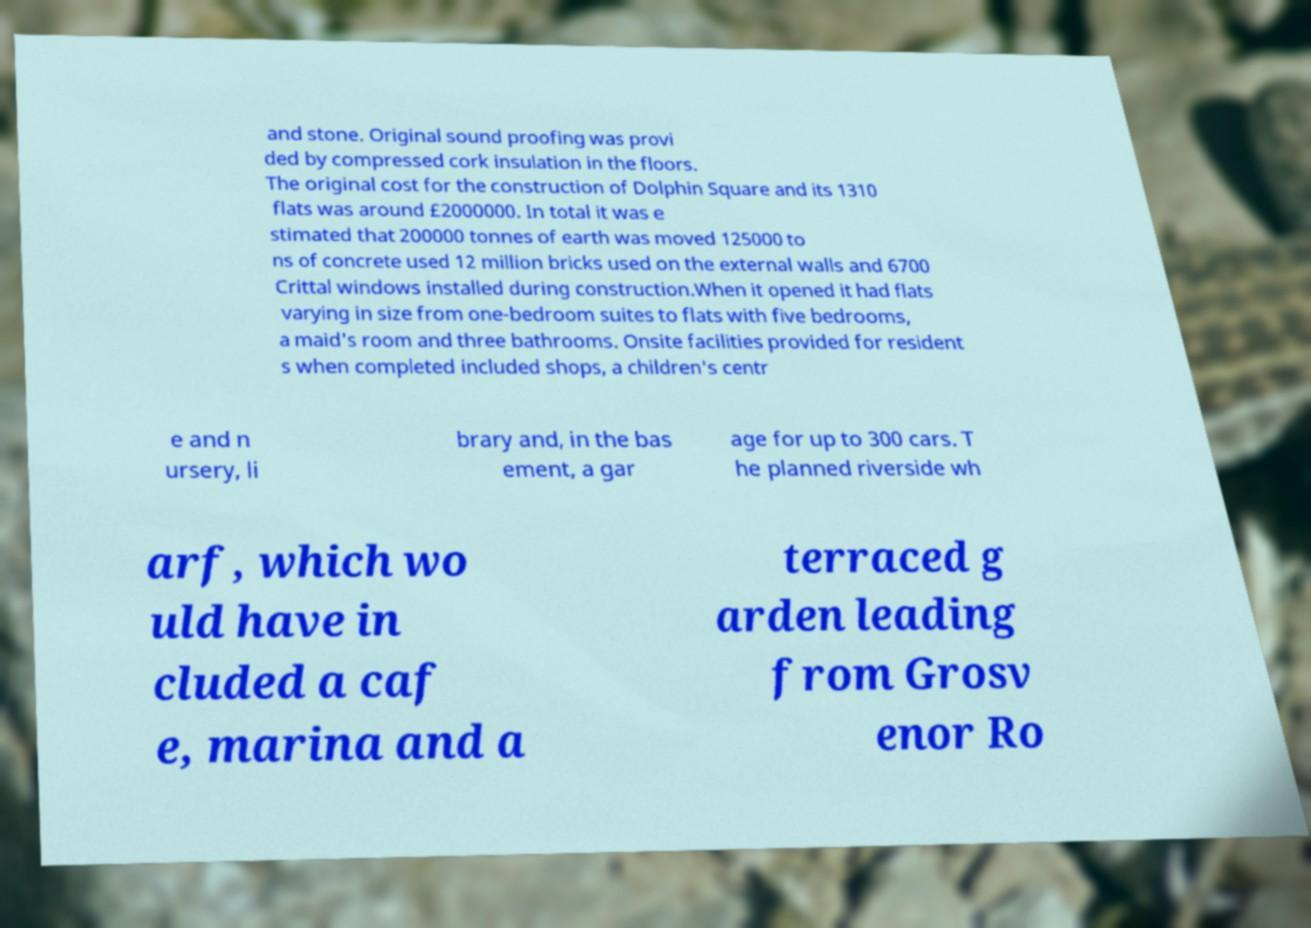Could you assist in decoding the text presented in this image and type it out clearly? and stone. Original sound proofing was provi ded by compressed cork insulation in the floors. The original cost for the construction of Dolphin Square and its 1310 flats was around £2000000. In total it was e stimated that 200000 tonnes of earth was moved 125000 to ns of concrete used 12 million bricks used on the external walls and 6700 Crittal windows installed during construction.When it opened it had flats varying in size from one-bedroom suites to flats with five bedrooms, a maid's room and three bathrooms. Onsite facilities provided for resident s when completed included shops, a children's centr e and n ursery, li brary and, in the bas ement, a gar age for up to 300 cars. T he planned riverside wh arf, which wo uld have in cluded a caf e, marina and a terraced g arden leading from Grosv enor Ro 